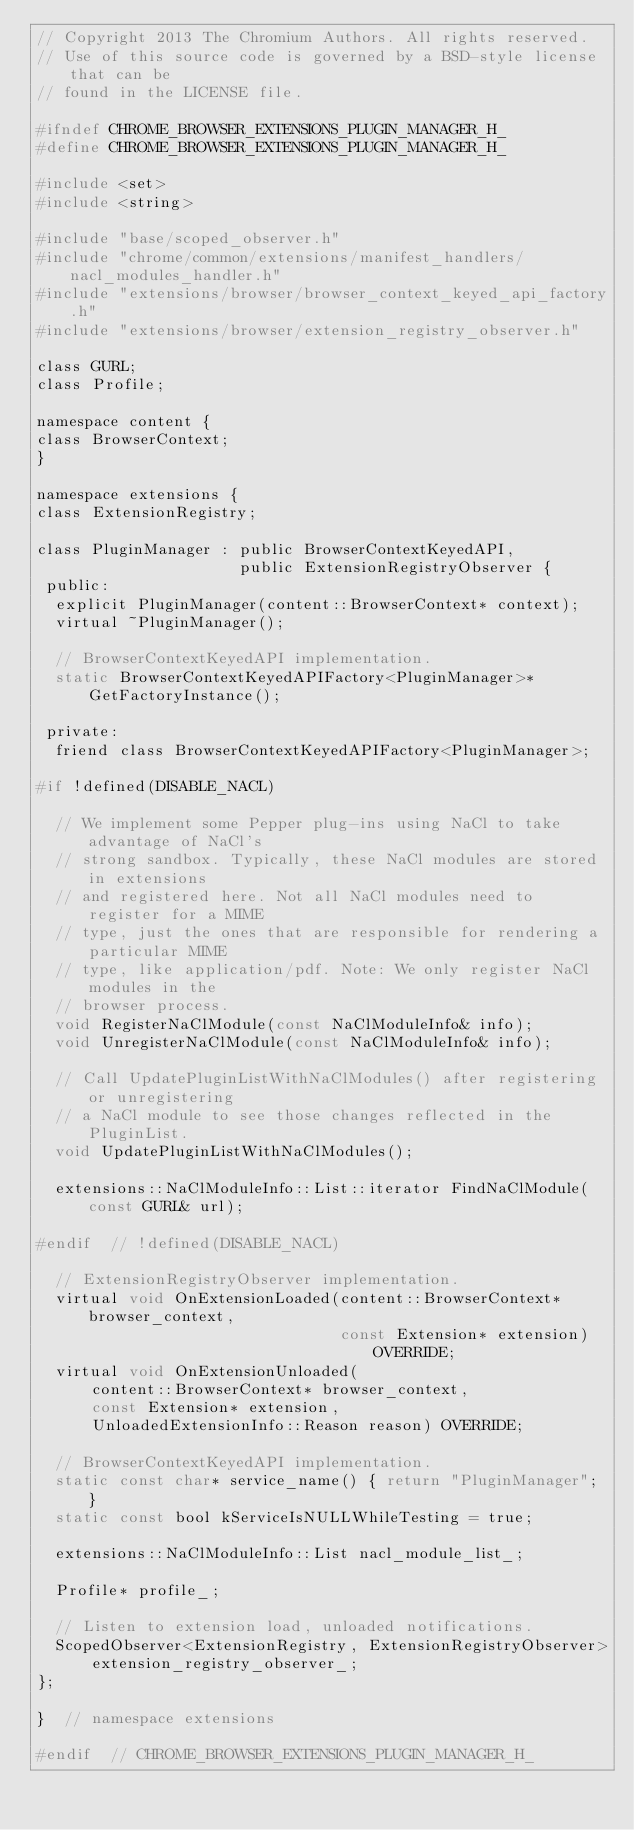<code> <loc_0><loc_0><loc_500><loc_500><_C_>// Copyright 2013 The Chromium Authors. All rights reserved.
// Use of this source code is governed by a BSD-style license that can be
// found in the LICENSE file.

#ifndef CHROME_BROWSER_EXTENSIONS_PLUGIN_MANAGER_H_
#define CHROME_BROWSER_EXTENSIONS_PLUGIN_MANAGER_H_

#include <set>
#include <string>

#include "base/scoped_observer.h"
#include "chrome/common/extensions/manifest_handlers/nacl_modules_handler.h"
#include "extensions/browser/browser_context_keyed_api_factory.h"
#include "extensions/browser/extension_registry_observer.h"

class GURL;
class Profile;

namespace content {
class BrowserContext;
}

namespace extensions {
class ExtensionRegistry;

class PluginManager : public BrowserContextKeyedAPI,
                      public ExtensionRegistryObserver {
 public:
  explicit PluginManager(content::BrowserContext* context);
  virtual ~PluginManager();

  // BrowserContextKeyedAPI implementation.
  static BrowserContextKeyedAPIFactory<PluginManager>* GetFactoryInstance();

 private:
  friend class BrowserContextKeyedAPIFactory<PluginManager>;

#if !defined(DISABLE_NACL)

  // We implement some Pepper plug-ins using NaCl to take advantage of NaCl's
  // strong sandbox. Typically, these NaCl modules are stored in extensions
  // and registered here. Not all NaCl modules need to register for a MIME
  // type, just the ones that are responsible for rendering a particular MIME
  // type, like application/pdf. Note: We only register NaCl modules in the
  // browser process.
  void RegisterNaClModule(const NaClModuleInfo& info);
  void UnregisterNaClModule(const NaClModuleInfo& info);

  // Call UpdatePluginListWithNaClModules() after registering or unregistering
  // a NaCl module to see those changes reflected in the PluginList.
  void UpdatePluginListWithNaClModules();

  extensions::NaClModuleInfo::List::iterator FindNaClModule(const GURL& url);

#endif  // !defined(DISABLE_NACL)

  // ExtensionRegistryObserver implementation.
  virtual void OnExtensionLoaded(content::BrowserContext* browser_context,
                                 const Extension* extension) OVERRIDE;
  virtual void OnExtensionUnloaded(
      content::BrowserContext* browser_context,
      const Extension* extension,
      UnloadedExtensionInfo::Reason reason) OVERRIDE;

  // BrowserContextKeyedAPI implementation.
  static const char* service_name() { return "PluginManager"; }
  static const bool kServiceIsNULLWhileTesting = true;

  extensions::NaClModuleInfo::List nacl_module_list_;

  Profile* profile_;

  // Listen to extension load, unloaded notifications.
  ScopedObserver<ExtensionRegistry, ExtensionRegistryObserver>
      extension_registry_observer_;
};

}  // namespace extensions

#endif  // CHROME_BROWSER_EXTENSIONS_PLUGIN_MANAGER_H_
</code> 